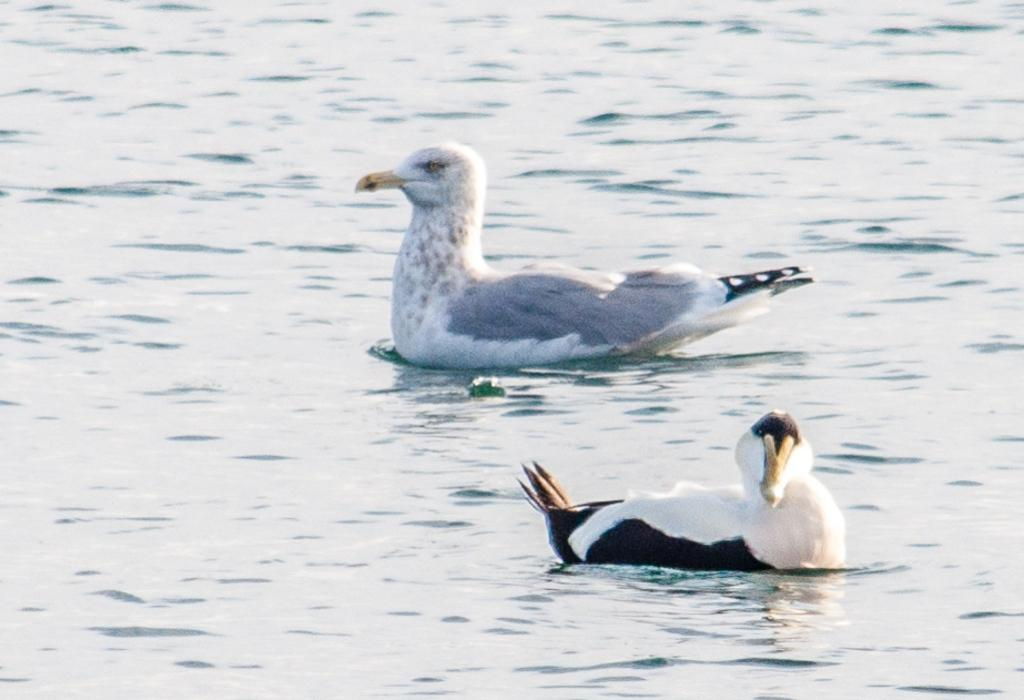What type of animals can be seen in the image? Birds can be seen in the image. Where are the birds situated in the image? The birds are in the water. What color is the holiday observed by the birds in the image? There is no holiday mentioned or depicted in the image, and the birds' color is not specified. 